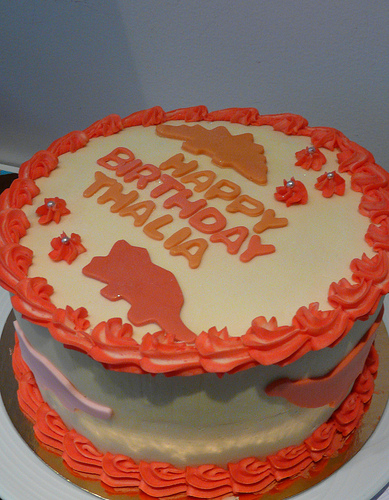<image>
Is there a cake under the wall? Yes. The cake is positioned underneath the wall, with the wall above it in the vertical space. Where is the pancake in relation to the bowl? Is it above the bowl? No. The pancake is not positioned above the bowl. The vertical arrangement shows a different relationship. 